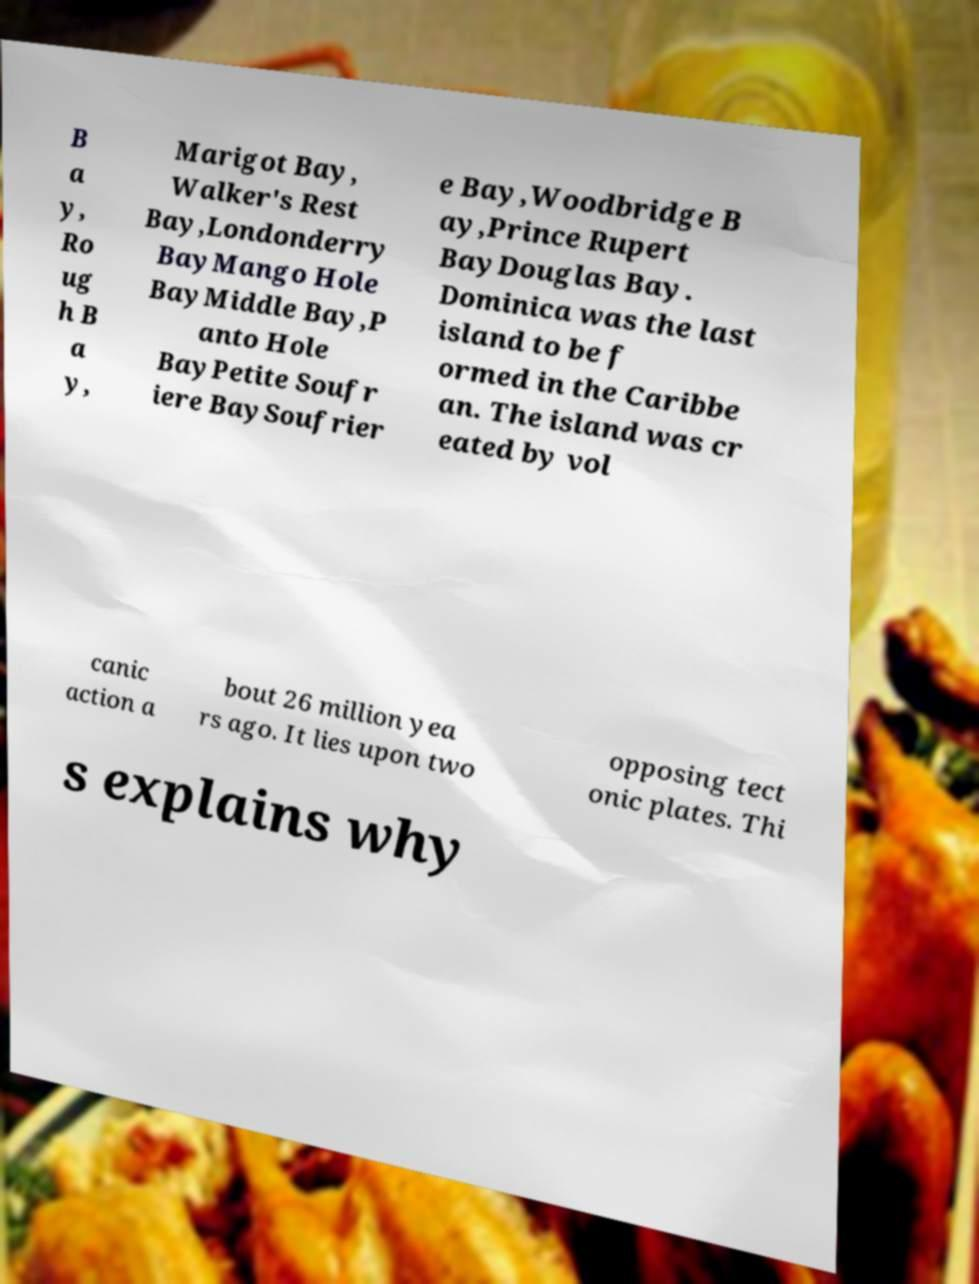For documentation purposes, I need the text within this image transcribed. Could you provide that? B a y, Ro ug h B a y, Marigot Bay, Walker's Rest Bay,Londonderry BayMango Hole BayMiddle Bay,P anto Hole BayPetite Soufr iere BaySoufrier e Bay,Woodbridge B ay,Prince Rupert BayDouglas Bay. Dominica was the last island to be f ormed in the Caribbe an. The island was cr eated by vol canic action a bout 26 million yea rs ago. It lies upon two opposing tect onic plates. Thi s explains why 